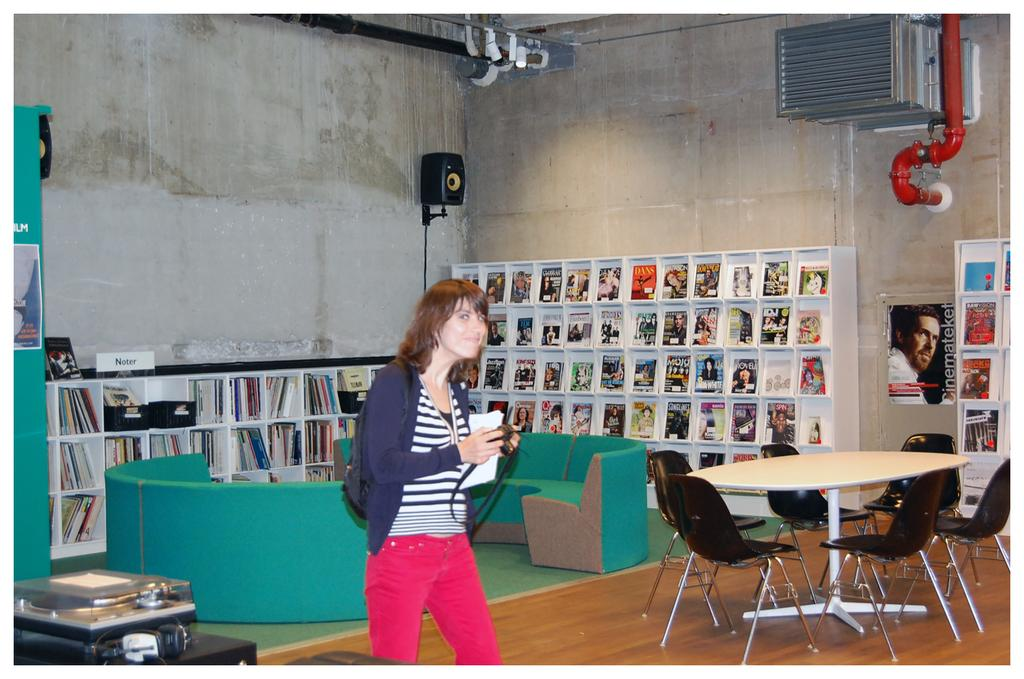What is the main subject in the room? There is a woman standing in the room. What can be seen in the background of the room? There are books in racks in the background. What type of furniture is present in the room? There is a table, a chair, and a couch in the room. What electronic device is in the room? There is a speaker in the room. What other object can be seen in the room? There is a pipe in the room. Can you tell me how many owls are sitting on the couch in the image? There are no owls present in the image; the couch is empty. What type of respect can be seen in the image? There is no indication of respect or any related actions in the image. 